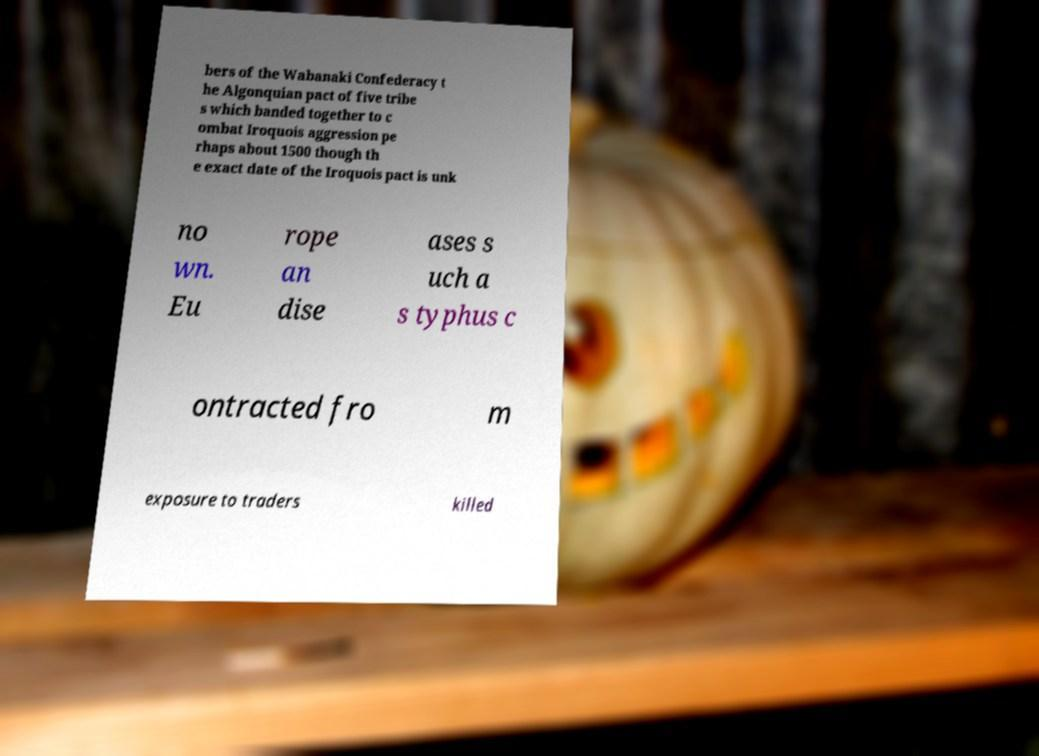Please read and relay the text visible in this image. What does it say? bers of the Wabanaki Confederacy t he Algonquian pact of five tribe s which banded together to c ombat Iroquois aggression pe rhaps about 1500 though th e exact date of the Iroquois pact is unk no wn. Eu rope an dise ases s uch a s typhus c ontracted fro m exposure to traders killed 